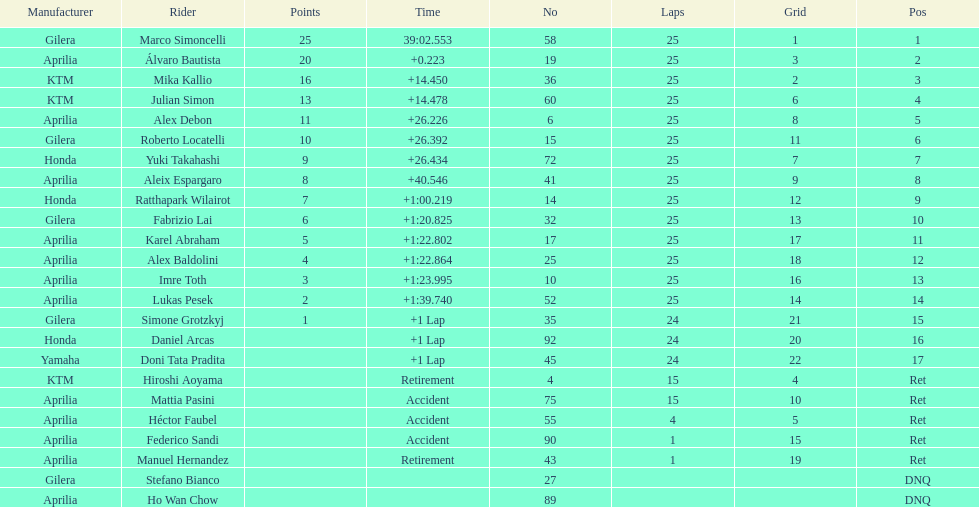What is the total number of rider? 24. 